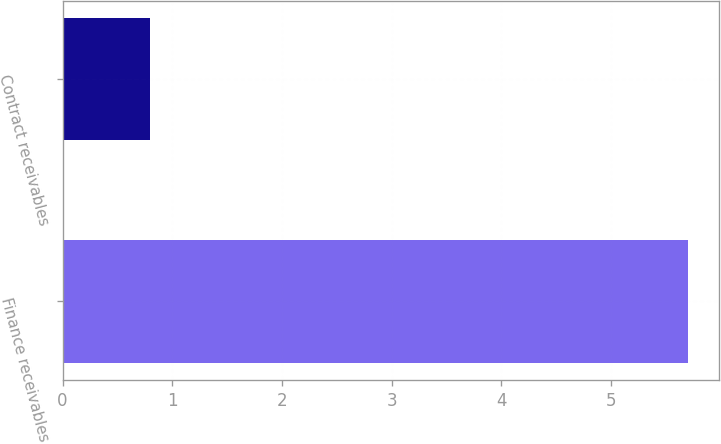<chart> <loc_0><loc_0><loc_500><loc_500><bar_chart><fcel>Finance receivables<fcel>Contract receivables<nl><fcel>5.7<fcel>0.8<nl></chart> 